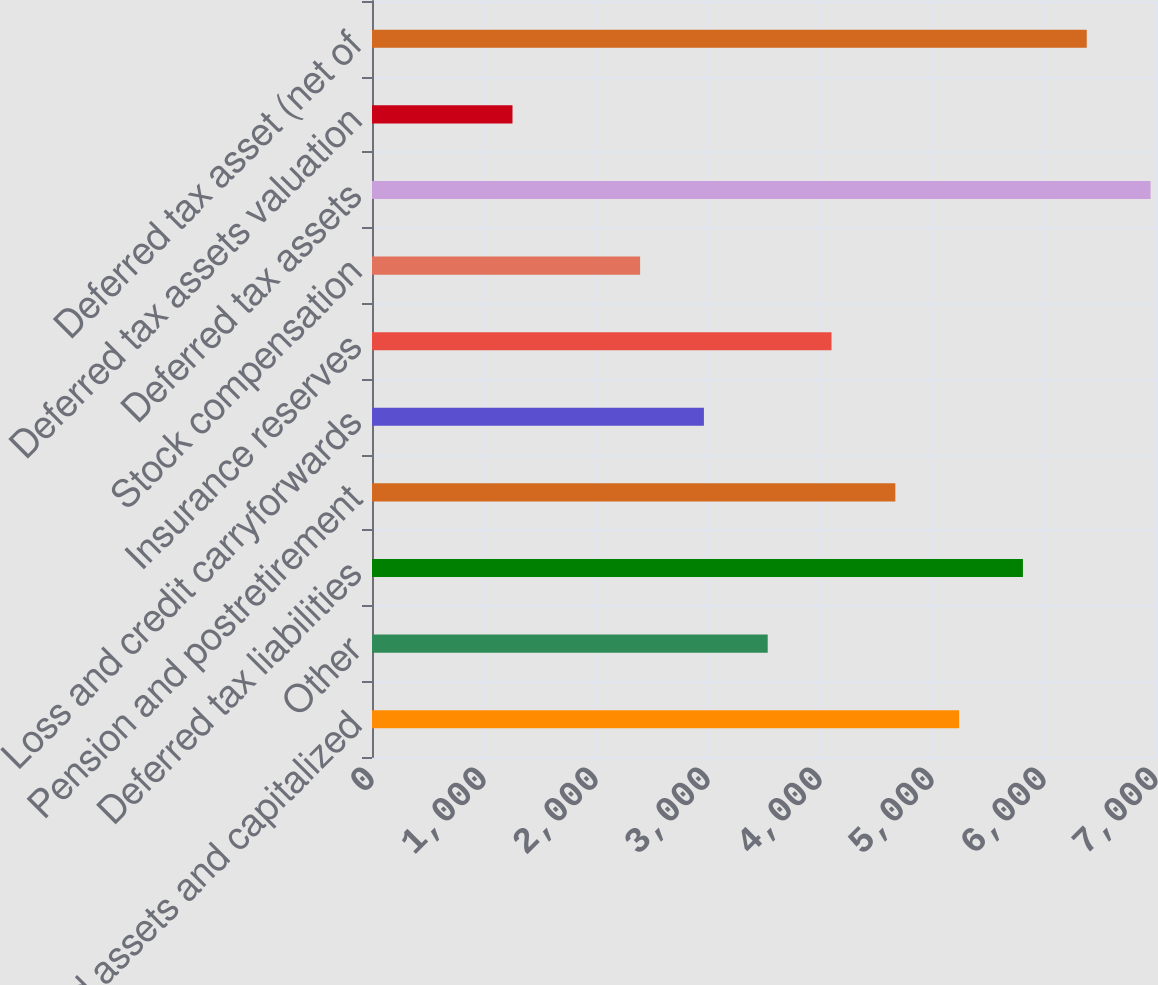<chart> <loc_0><loc_0><loc_500><loc_500><bar_chart><fcel>Fixed assets and capitalized<fcel>Other<fcel>Deferred tax liabilities<fcel>Pension and postretirement<fcel>Loss and credit carryforwards<fcel>Insurance reserves<fcel>Stock compensation<fcel>Deferred tax assets<fcel>Deferred tax assets valuation<fcel>Deferred tax asset (net of<nl><fcel>5242.3<fcel>3533.2<fcel>5812<fcel>4672.6<fcel>2963.5<fcel>4102.9<fcel>2393.8<fcel>6951.4<fcel>1254.4<fcel>6381.7<nl></chart> 